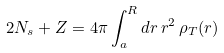Convert formula to latex. <formula><loc_0><loc_0><loc_500><loc_500>2 N _ { s } + Z = 4 \pi \int _ { a } ^ { R } d r \, r ^ { 2 } \, \rho _ { T } ( r )</formula> 